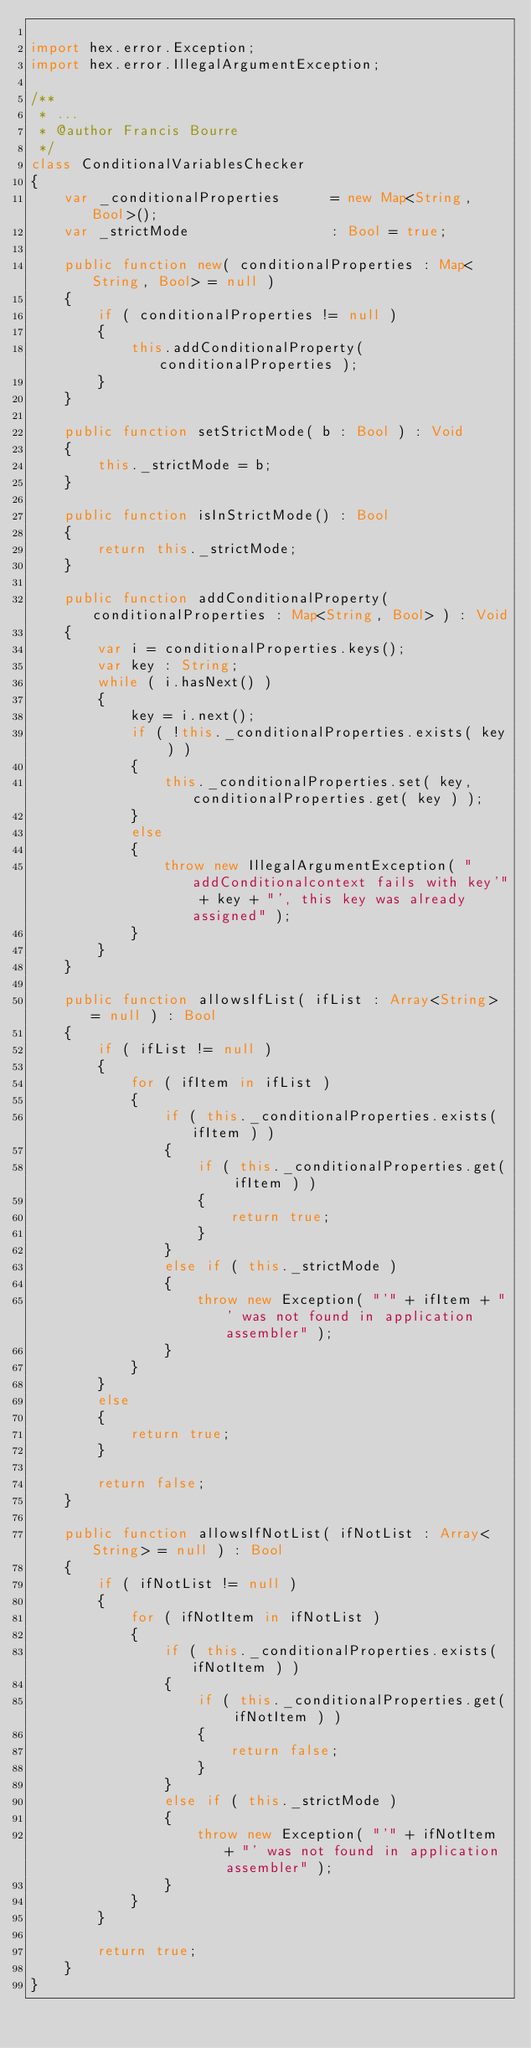Convert code to text. <code><loc_0><loc_0><loc_500><loc_500><_Haxe_>
import hex.error.Exception;
import hex.error.IllegalArgumentException;

/**
 * ...
 * @author Francis Bourre
 */
class ConditionalVariablesChecker
{
	var _conditionalProperties 		= new Map<String, Bool>();
	var _strictMode					: Bool = true;

	public function new( conditionalProperties : Map<String, Bool> = null ) 
	{
		if ( conditionalProperties != null )
		{
			this.addConditionalProperty( conditionalProperties );
		}
	}
	
	public function setStrictMode( b : Bool ) : Void
	{
		this._strictMode = b;
	}
	
	public function isInStrictMode() : Bool
	{
		return this._strictMode;
	}
	
	public function addConditionalProperty( conditionalProperties : Map<String, Bool> ) : Void
	{
		var i = conditionalProperties.keys();
		var key : String;
		while ( i.hasNext() )
		{
			key = i.next();
			if ( !this._conditionalProperties.exists( key ) )
			{
				this._conditionalProperties.set( key, conditionalProperties.get( key ) );
			}
			else
			{
				throw new IllegalArgumentException( "addConditionalcontext fails with key'" + key + "', this key was already assigned" );
			}
		}
	}
	
	public function allowsIfList( ifList : Array<String> = null ) : Bool
	{
		if ( ifList != null )
		{
			for ( ifItem in ifList )
			{
				if ( this._conditionalProperties.exists( ifItem ) )
				{
					if ( this._conditionalProperties.get( ifItem ) )
					{
						return true;
					}
				}
				else if ( this._strictMode )
				{
					throw new Exception( "'" + ifItem + "' was not found in application assembler" );
				}
			}
		}
		else
		{
			return true;
		}
		
		return false;
	}
	
	public function allowsIfNotList( ifNotList : Array<String> = null ) : Bool
	{
		if ( ifNotList != null )
		{
			for ( ifNotItem in ifNotList )
			{
				if ( this._conditionalProperties.exists( ifNotItem ) )
				{
					if ( this._conditionalProperties.get( ifNotItem ) )
					{
						return false;
					}
				}
				else if ( this._strictMode )
				{
					throw new Exception( "'" + ifNotItem + "' was not found in application assembler" );
				}
			}
		}
		
		return true;
	}
}</code> 